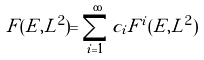<formula> <loc_0><loc_0><loc_500><loc_500>F ( E , L ^ { 2 } ) = \sum _ { i = 1 } ^ { \infty } c _ { i } F ^ { i } ( E , L ^ { 2 } )</formula> 